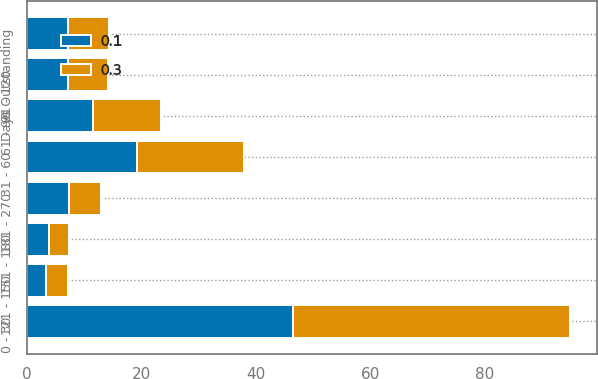Convert chart to OTSL. <chart><loc_0><loc_0><loc_500><loc_500><stacked_bar_chart><ecel><fcel>Days Outstanding<fcel>0 - 30<fcel>31 - 60<fcel>61 - 90<fcel>91 - 120<fcel>121 - 150<fcel>151 - 180<fcel>181 - 270<nl><fcel>0.3<fcel>7.2<fcel>48.4<fcel>18.6<fcel>11.9<fcel>7.1<fcel>3.8<fcel>3.6<fcel>5.7<nl><fcel>0.1<fcel>7.2<fcel>46.4<fcel>19.3<fcel>11.5<fcel>7.1<fcel>3.4<fcel>3.8<fcel>7.3<nl></chart> 